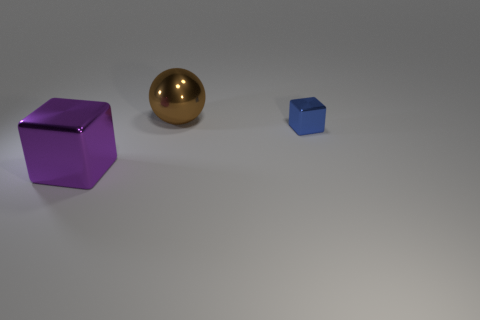Subtract all blue blocks. How many blocks are left? 1 Add 1 brown objects. How many objects exist? 4 Subtract 2 cubes. How many cubes are left? 0 Subtract all blue blocks. Subtract all tiny gray matte cubes. How many objects are left? 2 Add 1 purple blocks. How many purple blocks are left? 2 Add 2 large blue balls. How many large blue balls exist? 2 Subtract 0 yellow spheres. How many objects are left? 3 Subtract all balls. How many objects are left? 2 Subtract all cyan spheres. Subtract all brown blocks. How many spheres are left? 1 Subtract all yellow spheres. How many purple cubes are left? 1 